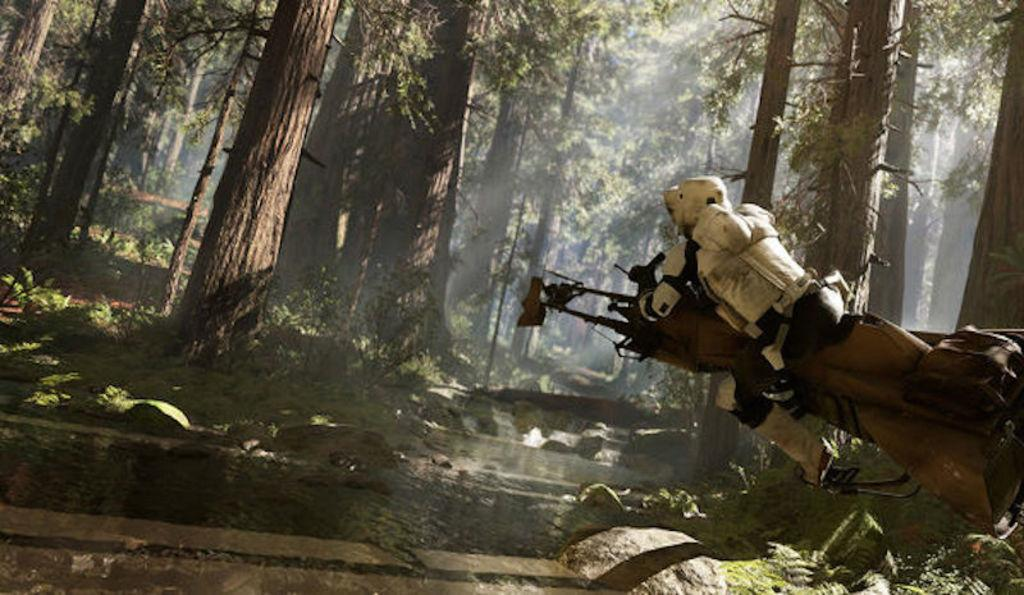What can be seen on the right side of the image? There is a person on the right side of the image. What is the person wearing? The person is wearing a white jacket. What type of environment is visible in the background of the image? There are trees and water visible in the background of the image. What rhythm is the person dancing to in the image? There is no indication of dancing or rhythm in the image; the person is simply standing on the right side. 